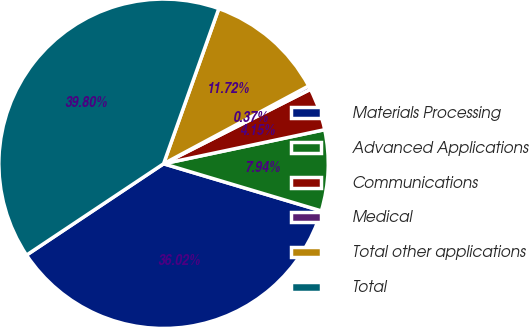Convert chart to OTSL. <chart><loc_0><loc_0><loc_500><loc_500><pie_chart><fcel>Materials Processing<fcel>Advanced Applications<fcel>Communications<fcel>Medical<fcel>Total other applications<fcel>Total<nl><fcel>36.02%<fcel>7.94%<fcel>4.15%<fcel>0.37%<fcel>11.72%<fcel>39.8%<nl></chart> 